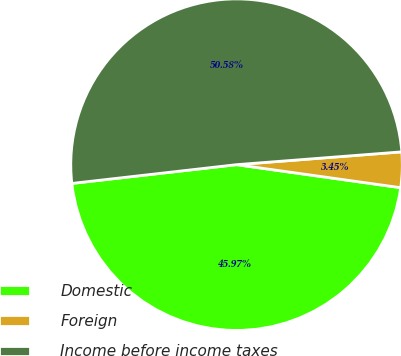Convert chart. <chart><loc_0><loc_0><loc_500><loc_500><pie_chart><fcel>Domestic<fcel>Foreign<fcel>Income before income taxes<nl><fcel>45.97%<fcel>3.45%<fcel>50.57%<nl></chart> 